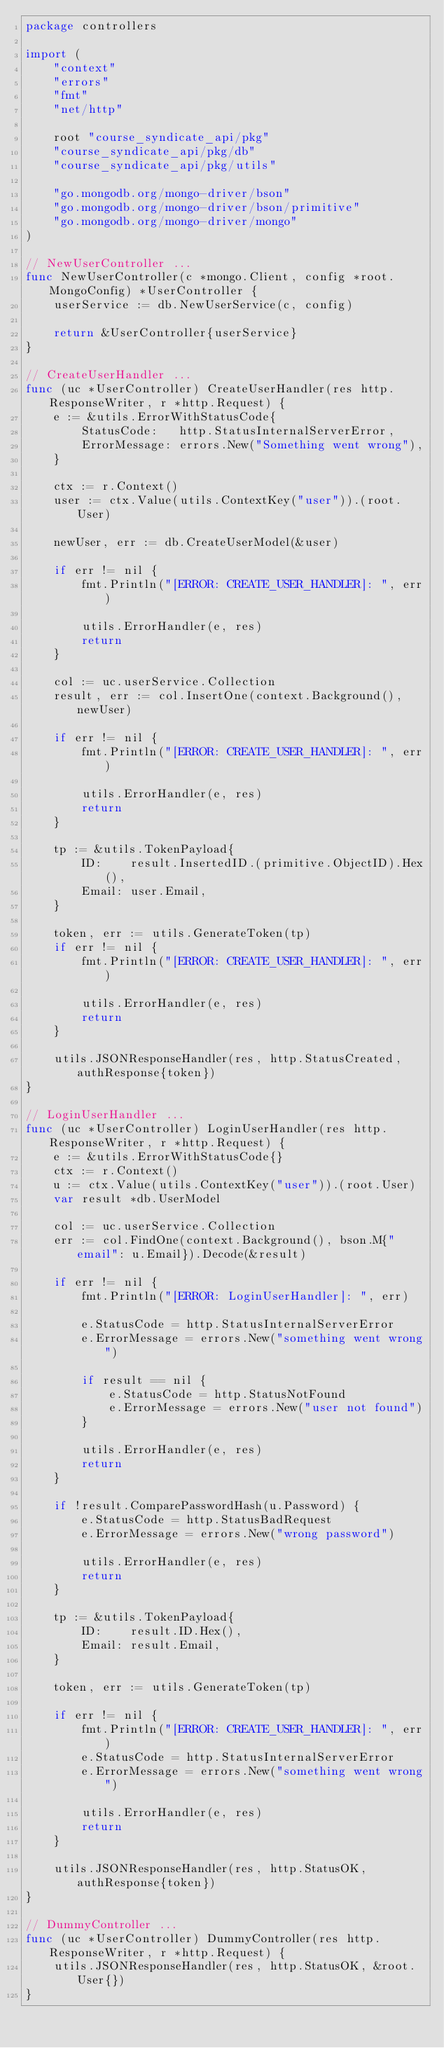<code> <loc_0><loc_0><loc_500><loc_500><_Go_>package controllers

import (
	"context"
	"errors"
	"fmt"
	"net/http"

	root "course_syndicate_api/pkg"
	"course_syndicate_api/pkg/db"
	"course_syndicate_api/pkg/utils"

	"go.mongodb.org/mongo-driver/bson"
	"go.mongodb.org/mongo-driver/bson/primitive"
	"go.mongodb.org/mongo-driver/mongo"
)

// NewUserController ...
func NewUserController(c *mongo.Client, config *root.MongoConfig) *UserController {
	userService := db.NewUserService(c, config)

	return &UserController{userService}
}

// CreateUserHandler ...
func (uc *UserController) CreateUserHandler(res http.ResponseWriter, r *http.Request) {
	e := &utils.ErrorWithStatusCode{
		StatusCode:   http.StatusInternalServerError,
		ErrorMessage: errors.New("Something went wrong"),
	}

	ctx := r.Context()
	user := ctx.Value(utils.ContextKey("user")).(root.User)

	newUser, err := db.CreateUserModel(&user)

	if err != nil {
		fmt.Println("[ERROR: CREATE_USER_HANDLER]: ", err)

		utils.ErrorHandler(e, res)
		return
	}

	col := uc.userService.Collection
	result, err := col.InsertOne(context.Background(), newUser)

	if err != nil {
		fmt.Println("[ERROR: CREATE_USER_HANDLER]: ", err)

		utils.ErrorHandler(e, res)
		return
	}

	tp := &utils.TokenPayload{
		ID:    result.InsertedID.(primitive.ObjectID).Hex(),
		Email: user.Email,
	}

	token, err := utils.GenerateToken(tp)
	if err != nil {
		fmt.Println("[ERROR: CREATE_USER_HANDLER]: ", err)

		utils.ErrorHandler(e, res)
		return
	}

	utils.JSONResponseHandler(res, http.StatusCreated, authResponse{token})
}

// LoginUserHandler ...
func (uc *UserController) LoginUserHandler(res http.ResponseWriter, r *http.Request) {
	e := &utils.ErrorWithStatusCode{}
	ctx := r.Context()
	u := ctx.Value(utils.ContextKey("user")).(root.User)
	var result *db.UserModel

	col := uc.userService.Collection
	err := col.FindOne(context.Background(), bson.M{"email": u.Email}).Decode(&result)

	if err != nil {
		fmt.Println("[ERROR: LoginUserHandler]: ", err)

		e.StatusCode = http.StatusInternalServerError
		e.ErrorMessage = errors.New("something went wrong")

		if result == nil {
			e.StatusCode = http.StatusNotFound
			e.ErrorMessage = errors.New("user not found")
		}

		utils.ErrorHandler(e, res)
		return
	}

	if !result.ComparePasswordHash(u.Password) {
		e.StatusCode = http.StatusBadRequest
		e.ErrorMessage = errors.New("wrong password")

		utils.ErrorHandler(e, res)
		return
	}

	tp := &utils.TokenPayload{
		ID:    result.ID.Hex(),
		Email: result.Email,
	}

	token, err := utils.GenerateToken(tp)

	if err != nil {
		fmt.Println("[ERROR: CREATE_USER_HANDLER]: ", err)
		e.StatusCode = http.StatusInternalServerError
		e.ErrorMessage = errors.New("something went wrong")

		utils.ErrorHandler(e, res)
		return
	}

	utils.JSONResponseHandler(res, http.StatusOK, authResponse{token})
}

// DummyController ...
func (uc *UserController) DummyController(res http.ResponseWriter, r *http.Request) {
	utils.JSONResponseHandler(res, http.StatusOK, &root.User{})
}
</code> 